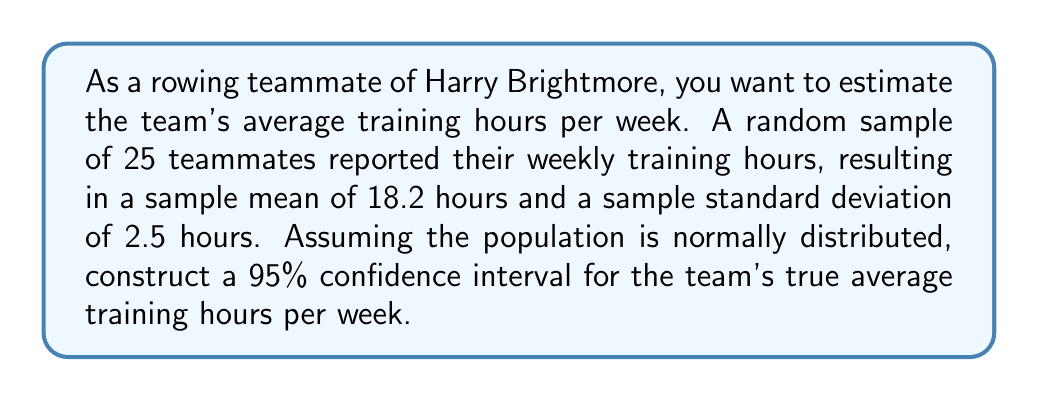Give your solution to this math problem. To construct a 95% confidence interval for the population mean, we'll use the t-distribution since we don't know the population standard deviation. We'll follow these steps:

1. Identify the known values:
   - Sample size: $n = 25$
   - Sample mean: $\bar{x} = 18.2$ hours
   - Sample standard deviation: $s = 2.5$ hours
   - Confidence level: 95% (α = 0.05)

2. Find the critical t-value:
   - Degrees of freedom: $df = n - 1 = 25 - 1 = 24$
   - For a 95% confidence interval, we need $t_{0.025, 24}$ (two-tailed)
   - From the t-distribution table: $t_{0.025, 24} ≈ 2.064$

3. Calculate the margin of error:
   $E = t_{0.025, 24} \cdot \frac{s}{\sqrt{n}} = 2.064 \cdot \frac{2.5}{\sqrt{25}} = 2.064 \cdot 0.5 = 1.032$

4. Construct the confidence interval:
   $CI = \bar{x} \pm E = 18.2 \pm 1.032$

5. Calculate the lower and upper bounds:
   Lower bound: $18.2 - 1.032 = 17.168$
   Upper bound: $18.2 + 1.032 = 19.232$

Therefore, we can be 95% confident that the true population mean of weekly training hours for the rowing team is between 17.168 and 19.232 hours.
Answer: (17.168, 19.232) hours 